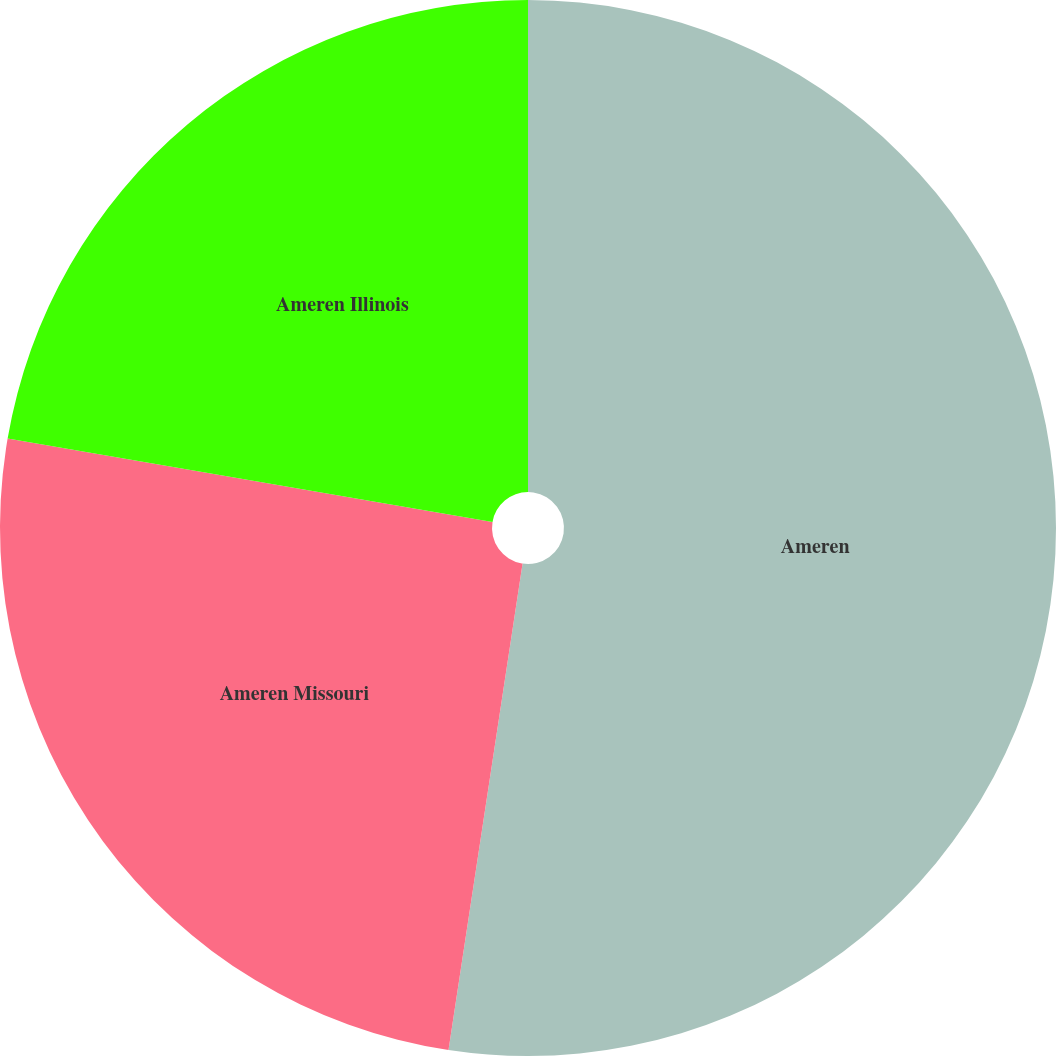Convert chart to OTSL. <chart><loc_0><loc_0><loc_500><loc_500><pie_chart><fcel>Ameren<fcel>Ameren Missouri<fcel>Ameren Illinois<nl><fcel>52.4%<fcel>25.3%<fcel>22.29%<nl></chart> 